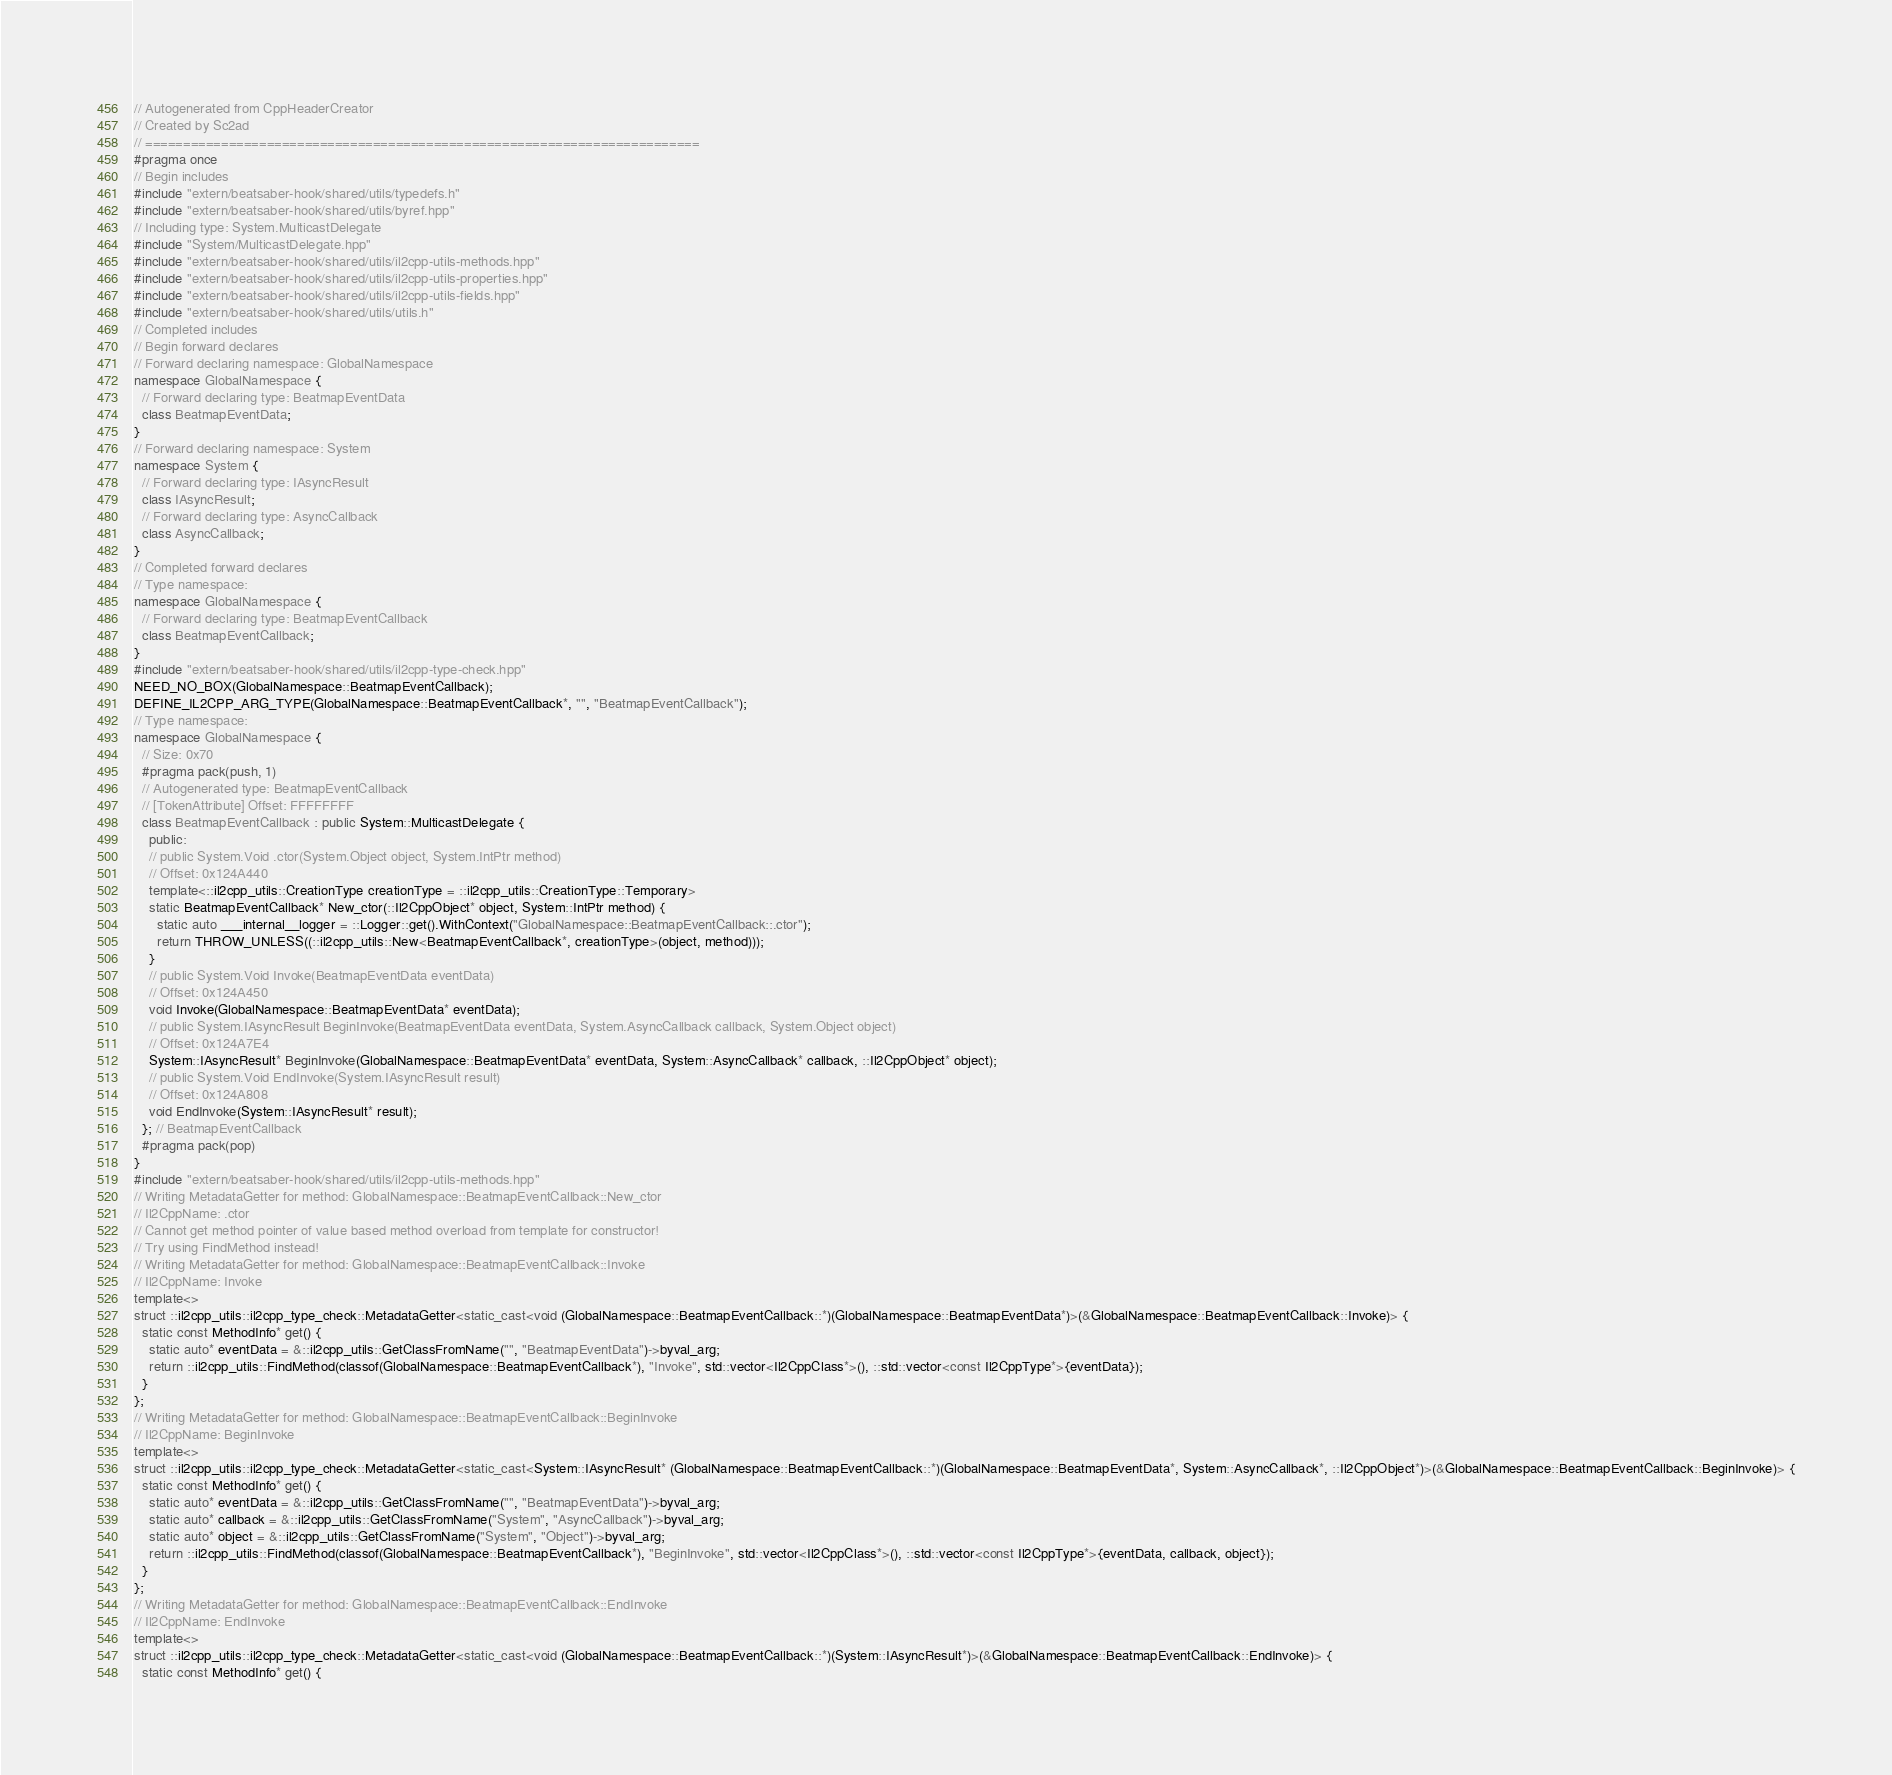<code> <loc_0><loc_0><loc_500><loc_500><_C++_>// Autogenerated from CppHeaderCreator
// Created by Sc2ad
// =========================================================================
#pragma once
// Begin includes
#include "extern/beatsaber-hook/shared/utils/typedefs.h"
#include "extern/beatsaber-hook/shared/utils/byref.hpp"
// Including type: System.MulticastDelegate
#include "System/MulticastDelegate.hpp"
#include "extern/beatsaber-hook/shared/utils/il2cpp-utils-methods.hpp"
#include "extern/beatsaber-hook/shared/utils/il2cpp-utils-properties.hpp"
#include "extern/beatsaber-hook/shared/utils/il2cpp-utils-fields.hpp"
#include "extern/beatsaber-hook/shared/utils/utils.h"
// Completed includes
// Begin forward declares
// Forward declaring namespace: GlobalNamespace
namespace GlobalNamespace {
  // Forward declaring type: BeatmapEventData
  class BeatmapEventData;
}
// Forward declaring namespace: System
namespace System {
  // Forward declaring type: IAsyncResult
  class IAsyncResult;
  // Forward declaring type: AsyncCallback
  class AsyncCallback;
}
// Completed forward declares
// Type namespace: 
namespace GlobalNamespace {
  // Forward declaring type: BeatmapEventCallback
  class BeatmapEventCallback;
}
#include "extern/beatsaber-hook/shared/utils/il2cpp-type-check.hpp"
NEED_NO_BOX(GlobalNamespace::BeatmapEventCallback);
DEFINE_IL2CPP_ARG_TYPE(GlobalNamespace::BeatmapEventCallback*, "", "BeatmapEventCallback");
// Type namespace: 
namespace GlobalNamespace {
  // Size: 0x70
  #pragma pack(push, 1)
  // Autogenerated type: BeatmapEventCallback
  // [TokenAttribute] Offset: FFFFFFFF
  class BeatmapEventCallback : public System::MulticastDelegate {
    public:
    // public System.Void .ctor(System.Object object, System.IntPtr method)
    // Offset: 0x124A440
    template<::il2cpp_utils::CreationType creationType = ::il2cpp_utils::CreationType::Temporary>
    static BeatmapEventCallback* New_ctor(::Il2CppObject* object, System::IntPtr method) {
      static auto ___internal__logger = ::Logger::get().WithContext("GlobalNamespace::BeatmapEventCallback::.ctor");
      return THROW_UNLESS((::il2cpp_utils::New<BeatmapEventCallback*, creationType>(object, method)));
    }
    // public System.Void Invoke(BeatmapEventData eventData)
    // Offset: 0x124A450
    void Invoke(GlobalNamespace::BeatmapEventData* eventData);
    // public System.IAsyncResult BeginInvoke(BeatmapEventData eventData, System.AsyncCallback callback, System.Object object)
    // Offset: 0x124A7E4
    System::IAsyncResult* BeginInvoke(GlobalNamespace::BeatmapEventData* eventData, System::AsyncCallback* callback, ::Il2CppObject* object);
    // public System.Void EndInvoke(System.IAsyncResult result)
    // Offset: 0x124A808
    void EndInvoke(System::IAsyncResult* result);
  }; // BeatmapEventCallback
  #pragma pack(pop)
}
#include "extern/beatsaber-hook/shared/utils/il2cpp-utils-methods.hpp"
// Writing MetadataGetter for method: GlobalNamespace::BeatmapEventCallback::New_ctor
// Il2CppName: .ctor
// Cannot get method pointer of value based method overload from template for constructor!
// Try using FindMethod instead!
// Writing MetadataGetter for method: GlobalNamespace::BeatmapEventCallback::Invoke
// Il2CppName: Invoke
template<>
struct ::il2cpp_utils::il2cpp_type_check::MetadataGetter<static_cast<void (GlobalNamespace::BeatmapEventCallback::*)(GlobalNamespace::BeatmapEventData*)>(&GlobalNamespace::BeatmapEventCallback::Invoke)> {
  static const MethodInfo* get() {
    static auto* eventData = &::il2cpp_utils::GetClassFromName("", "BeatmapEventData")->byval_arg;
    return ::il2cpp_utils::FindMethod(classof(GlobalNamespace::BeatmapEventCallback*), "Invoke", std::vector<Il2CppClass*>(), ::std::vector<const Il2CppType*>{eventData});
  }
};
// Writing MetadataGetter for method: GlobalNamespace::BeatmapEventCallback::BeginInvoke
// Il2CppName: BeginInvoke
template<>
struct ::il2cpp_utils::il2cpp_type_check::MetadataGetter<static_cast<System::IAsyncResult* (GlobalNamespace::BeatmapEventCallback::*)(GlobalNamespace::BeatmapEventData*, System::AsyncCallback*, ::Il2CppObject*)>(&GlobalNamespace::BeatmapEventCallback::BeginInvoke)> {
  static const MethodInfo* get() {
    static auto* eventData = &::il2cpp_utils::GetClassFromName("", "BeatmapEventData")->byval_arg;
    static auto* callback = &::il2cpp_utils::GetClassFromName("System", "AsyncCallback")->byval_arg;
    static auto* object = &::il2cpp_utils::GetClassFromName("System", "Object")->byval_arg;
    return ::il2cpp_utils::FindMethod(classof(GlobalNamespace::BeatmapEventCallback*), "BeginInvoke", std::vector<Il2CppClass*>(), ::std::vector<const Il2CppType*>{eventData, callback, object});
  }
};
// Writing MetadataGetter for method: GlobalNamespace::BeatmapEventCallback::EndInvoke
// Il2CppName: EndInvoke
template<>
struct ::il2cpp_utils::il2cpp_type_check::MetadataGetter<static_cast<void (GlobalNamespace::BeatmapEventCallback::*)(System::IAsyncResult*)>(&GlobalNamespace::BeatmapEventCallback::EndInvoke)> {
  static const MethodInfo* get() {</code> 